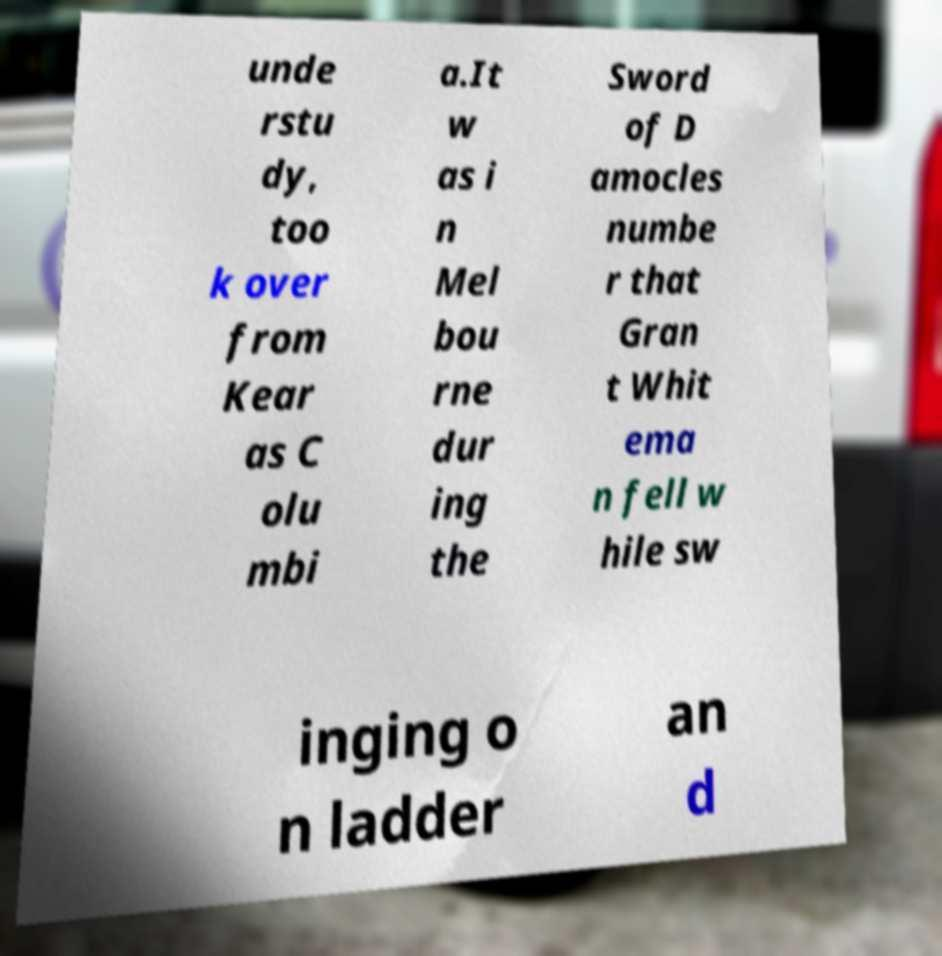Can you read and provide the text displayed in the image?This photo seems to have some interesting text. Can you extract and type it out for me? unde rstu dy, too k over from Kear as C olu mbi a.It w as i n Mel bou rne dur ing the Sword of D amocles numbe r that Gran t Whit ema n fell w hile sw inging o n ladder an d 